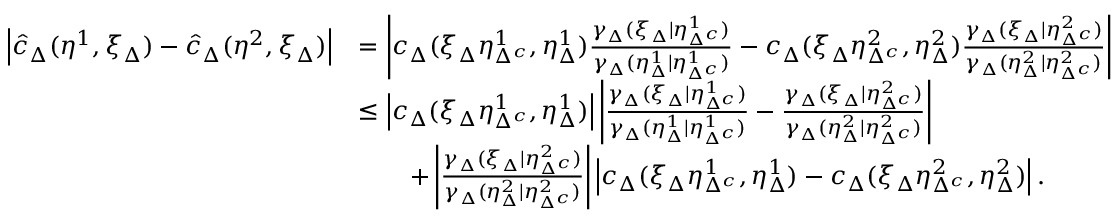<formula> <loc_0><loc_0><loc_500><loc_500>\begin{array} { r l } { \left | \hat { c } _ { \Delta } ( \eta ^ { 1 } , \xi _ { \Delta } ) - \hat { c } _ { \Delta } ( \eta ^ { 2 } , \xi _ { \Delta } ) \right | } & { = \left | c _ { \Delta } ( \xi _ { \Delta } \eta _ { \Delta ^ { c } } ^ { 1 } , \eta _ { \Delta } ^ { 1 } ) \frac { \gamma _ { \Delta } ( \xi _ { \Delta } | \eta _ { \Delta ^ { c } } ^ { 1 } ) } { \gamma _ { \Delta } ( \eta _ { \Delta } ^ { 1 } | \eta _ { \Delta ^ { c } } ^ { 1 } ) } - c _ { \Delta } ( \xi _ { \Delta } \eta _ { \Delta ^ { c } } ^ { 2 } , \eta _ { \Delta } ^ { 2 } ) \frac { \gamma _ { \Delta } ( \xi _ { \Delta } | \eta _ { \Delta ^ { c } } ^ { 2 } ) } { \gamma _ { \Delta } ( \eta _ { \Delta } ^ { 2 } | \eta _ { \Delta ^ { c } } ^ { 2 } ) } \right | } \\ { \ } & { \leq \left | c _ { \Delta } ( \xi _ { \Delta } \eta _ { \Delta ^ { c } } ^ { 1 } , \eta _ { \Delta } ^ { 1 } ) \right | \left | \frac { \gamma _ { \Delta } ( \xi _ { \Delta } | \eta _ { \Delta ^ { c } } ^ { 1 } ) } { \gamma _ { \Delta } ( \eta _ { \Delta } ^ { 1 } | \eta _ { \Delta ^ { c } } ^ { 1 } ) } - \frac { \gamma _ { \Delta } ( \xi _ { \Delta } | \eta _ { \Delta ^ { c } } ^ { 2 } ) } { \gamma _ { \Delta } ( \eta _ { \Delta } ^ { 2 } | \eta _ { \Delta ^ { c } } ^ { 2 } ) } \right | } \\ { \ } & { \quad + \left | \frac { \gamma _ { \Delta } ( \xi _ { \Delta } | \eta _ { \Delta ^ { c } } ^ { 2 } ) } { \gamma _ { \Delta } ( \eta _ { \Delta } ^ { 2 } | \eta _ { \Delta ^ { c } } ^ { 2 } ) } \right | \left | c _ { \Delta } ( \xi _ { \Delta } \eta _ { \Delta ^ { c } } ^ { 1 } , \eta _ { \Delta } ^ { 1 } ) - c _ { \Delta } ( \xi _ { \Delta } \eta _ { \Delta ^ { c } } ^ { 2 } , \eta _ { \Delta } ^ { 2 } ) \right | . } \end{array}</formula> 